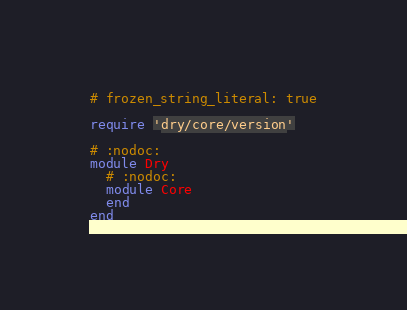<code> <loc_0><loc_0><loc_500><loc_500><_Ruby_># frozen_string_literal: true

require 'dry/core/version'

# :nodoc:
module Dry
  # :nodoc:
  module Core
  end
end
</code> 